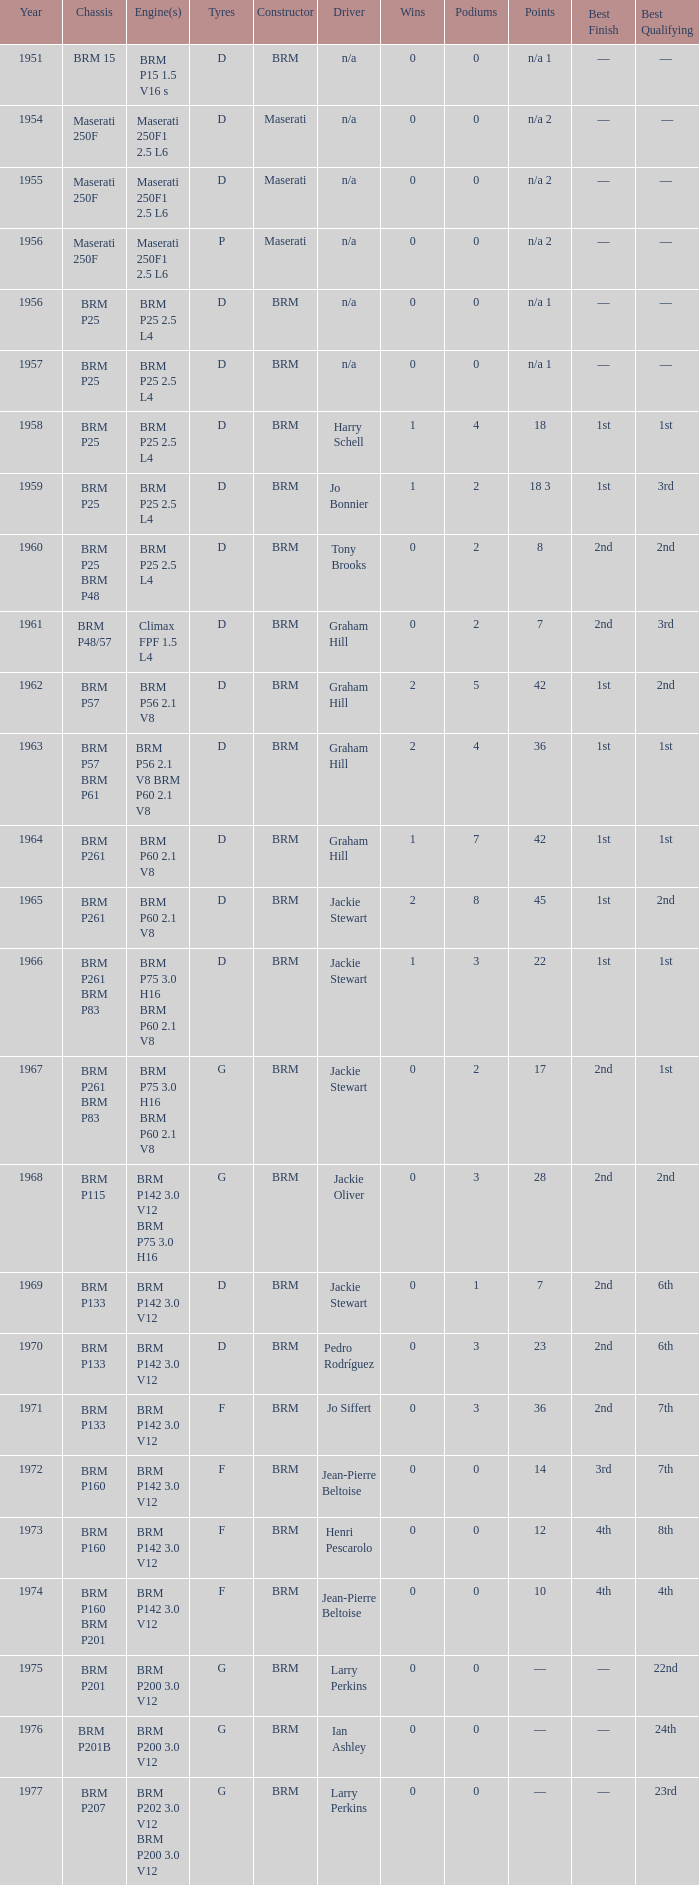Name the chassis for 1970 and tyres of d BRM P133. 